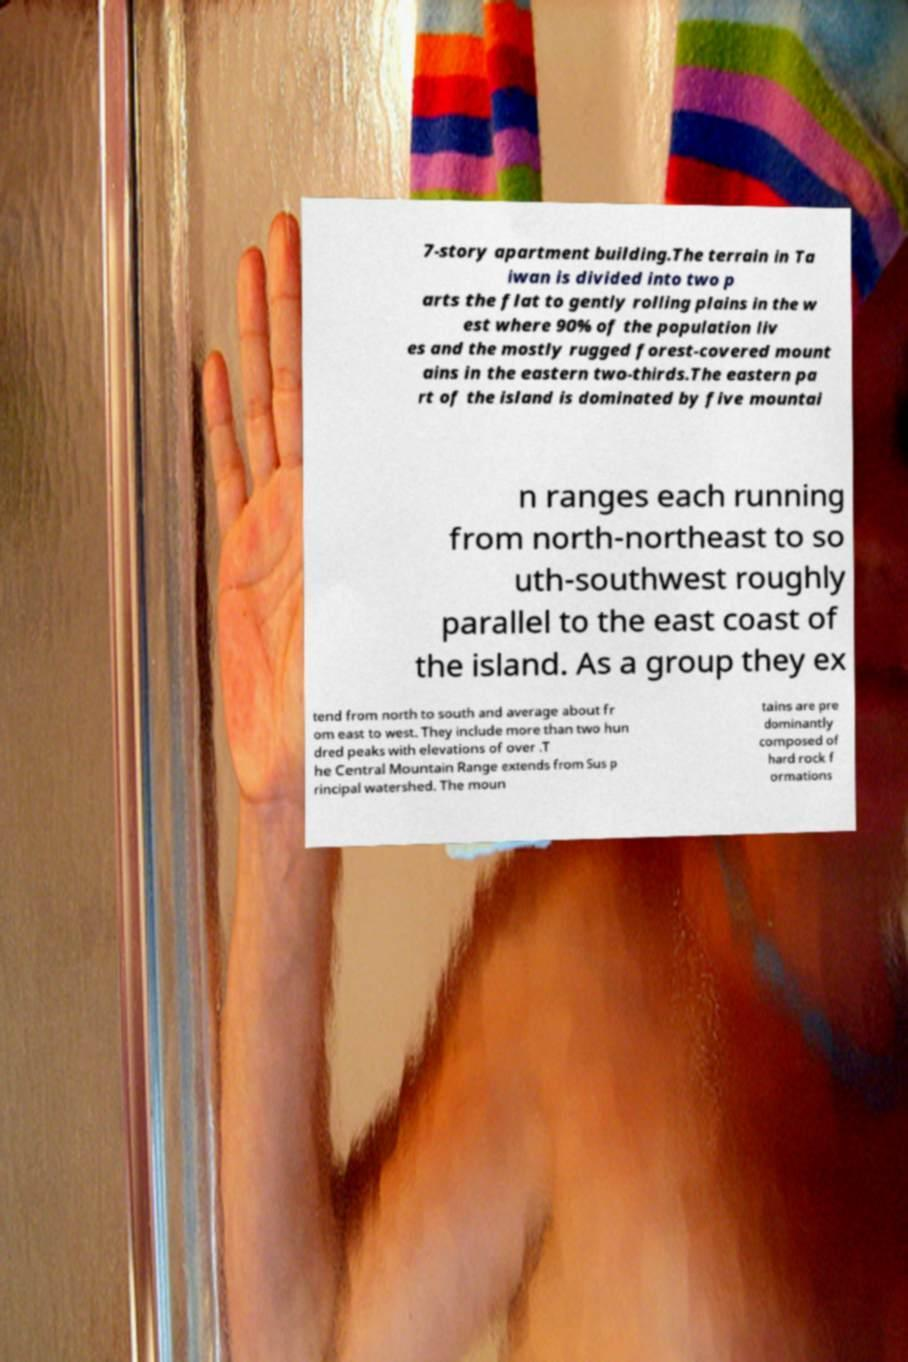Could you extract and type out the text from this image? 7-story apartment building.The terrain in Ta iwan is divided into two p arts the flat to gently rolling plains in the w est where 90% of the population liv es and the mostly rugged forest-covered mount ains in the eastern two-thirds.The eastern pa rt of the island is dominated by five mountai n ranges each running from north-northeast to so uth-southwest roughly parallel to the east coast of the island. As a group they ex tend from north to south and average about fr om east to west. They include more than two hun dred peaks with elevations of over .T he Central Mountain Range extends from Sus p rincipal watershed. The moun tains are pre dominantly composed of hard rock f ormations 